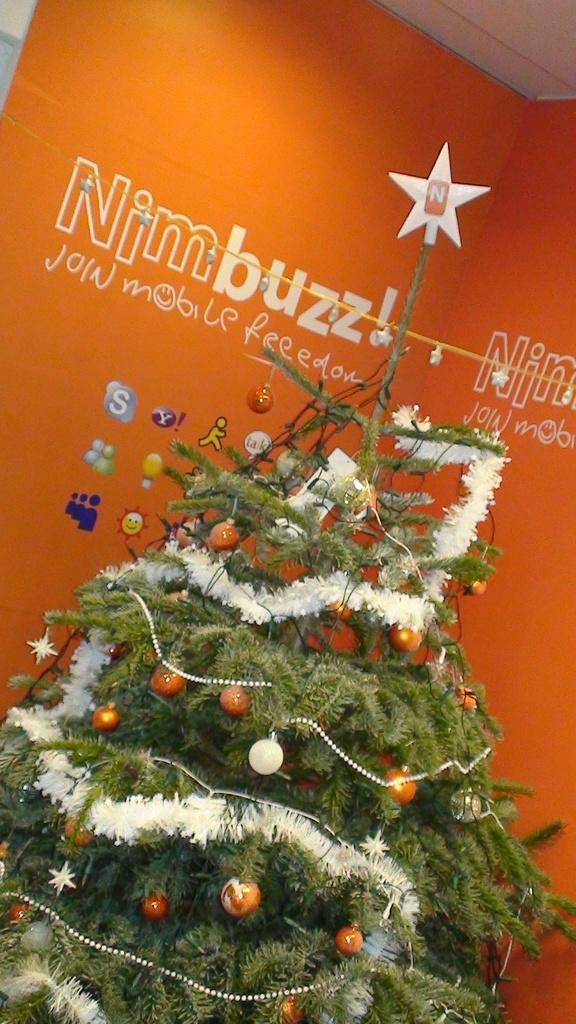What is the main subject of the image? There is a Christmas tree in the image. What features does the Christmas tree have? The Christmas tree has lights and decorative items. What is visible in the background of the image? There is a poster in the background of the image. What elements are present on the poster? The poster has text and pictures. What type of trade is being conducted in the image? There is no indication of any trade being conducted in the image; it primarily features a Christmas tree and a poster. What color is the star on the vest in the image? There is no vest or star present in the image. 